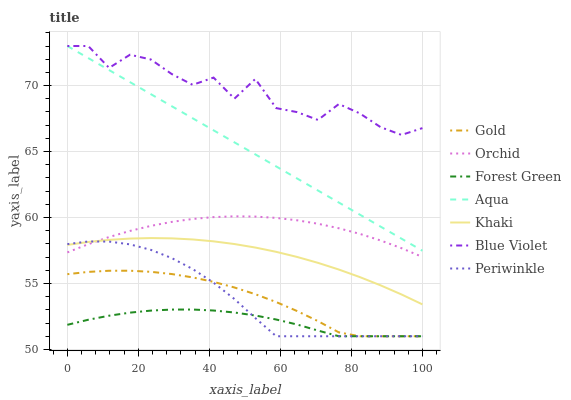Does Forest Green have the minimum area under the curve?
Answer yes or no. Yes. Does Blue Violet have the maximum area under the curve?
Answer yes or no. Yes. Does Gold have the minimum area under the curve?
Answer yes or no. No. Does Gold have the maximum area under the curve?
Answer yes or no. No. Is Aqua the smoothest?
Answer yes or no. Yes. Is Blue Violet the roughest?
Answer yes or no. Yes. Is Gold the smoothest?
Answer yes or no. No. Is Gold the roughest?
Answer yes or no. No. Does Gold have the lowest value?
Answer yes or no. Yes. Does Aqua have the lowest value?
Answer yes or no. No. Does Blue Violet have the highest value?
Answer yes or no. Yes. Does Gold have the highest value?
Answer yes or no. No. Is Forest Green less than Khaki?
Answer yes or no. Yes. Is Aqua greater than Periwinkle?
Answer yes or no. Yes. Does Periwinkle intersect Gold?
Answer yes or no. Yes. Is Periwinkle less than Gold?
Answer yes or no. No. Is Periwinkle greater than Gold?
Answer yes or no. No. Does Forest Green intersect Khaki?
Answer yes or no. No. 